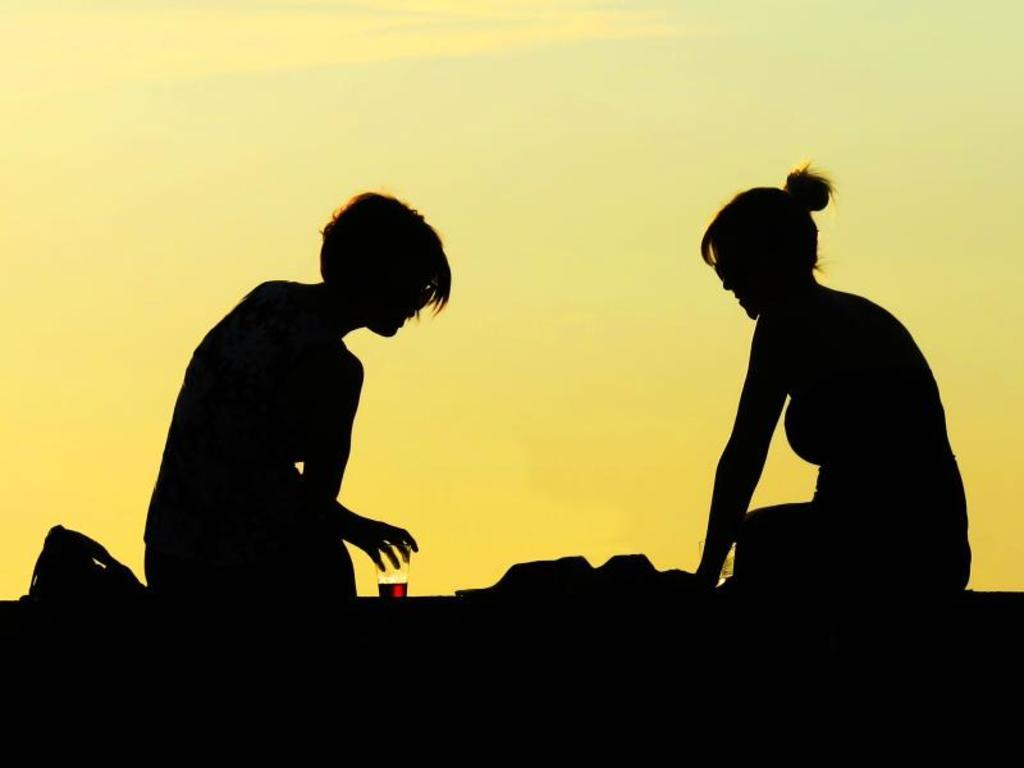Who is present in the image? There is a man and a woman in the image. What are the man and woman doing in the image? The man and woman are sitting on the land in the image. What object can be seen in the image? There is a glass in the image. What can be seen in the background of the image? There is a sky visible in the background of the image. What type of kite is the man holding in the image? There is no kite present in the image; the man and woman are sitting on the land. What event is taking place in the image? The image does not depict a specific event; it simply shows a man and a woman sitting on the land with a glass nearby. 